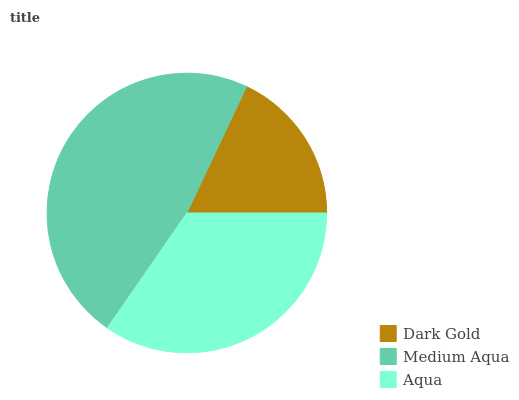Is Dark Gold the minimum?
Answer yes or no. Yes. Is Medium Aqua the maximum?
Answer yes or no. Yes. Is Aqua the minimum?
Answer yes or no. No. Is Aqua the maximum?
Answer yes or no. No. Is Medium Aqua greater than Aqua?
Answer yes or no. Yes. Is Aqua less than Medium Aqua?
Answer yes or no. Yes. Is Aqua greater than Medium Aqua?
Answer yes or no. No. Is Medium Aqua less than Aqua?
Answer yes or no. No. Is Aqua the high median?
Answer yes or no. Yes. Is Aqua the low median?
Answer yes or no. Yes. Is Dark Gold the high median?
Answer yes or no. No. Is Medium Aqua the low median?
Answer yes or no. No. 